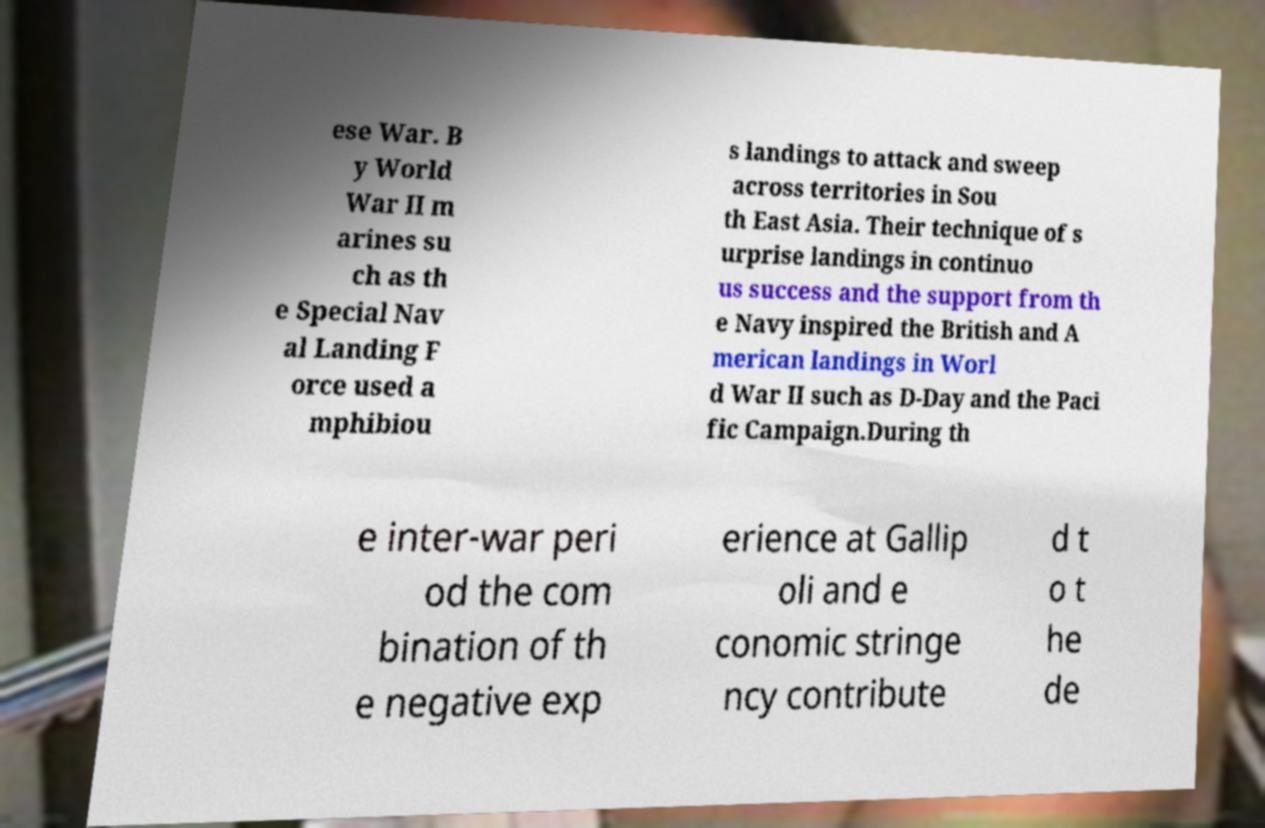For documentation purposes, I need the text within this image transcribed. Could you provide that? ese War. B y World War II m arines su ch as th e Special Nav al Landing F orce used a mphibiou s landings to attack and sweep across territories in Sou th East Asia. Their technique of s urprise landings in continuo us success and the support from th e Navy inspired the British and A merican landings in Worl d War II such as D-Day and the Paci fic Campaign.During th e inter-war peri od the com bination of th e negative exp erience at Gallip oli and e conomic stringe ncy contribute d t o t he de 